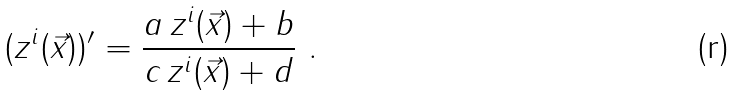<formula> <loc_0><loc_0><loc_500><loc_500>( z ^ { i } ( \vec { x } ) ) ^ { \prime } = \frac { a \, z ^ { i } ( \vec { x } ) + b } { c \, z ^ { i } ( \vec { x } ) + d } \ .</formula> 